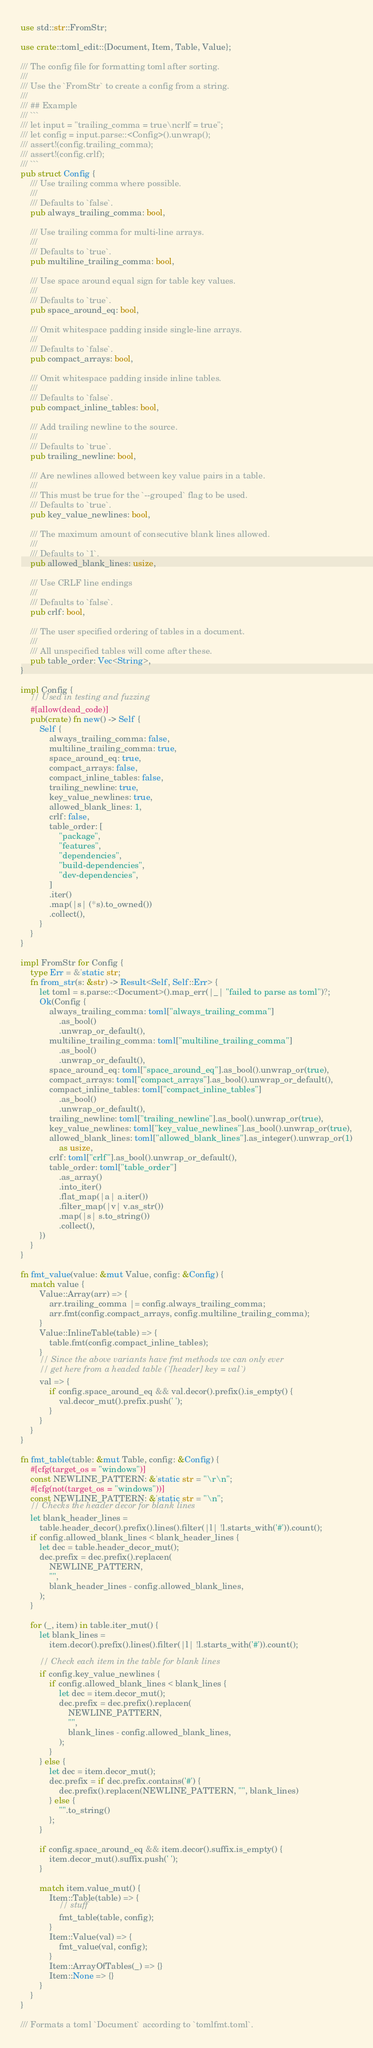Convert code to text. <code><loc_0><loc_0><loc_500><loc_500><_Rust_>use std::str::FromStr;

use crate::toml_edit::{Document, Item, Table, Value};

/// The config file for formatting toml after sorting.
///
/// Use the `FromStr` to create a config from a string.
///
/// ## Example
/// ```
/// let input = "trailing_comma = true\ncrlf = true";
/// let config = input.parse::<Config>().unwrap();
/// assert!(config.trailing_comma);
/// assert!(config.crlf);
/// ```
pub struct Config {
    /// Use trailing comma where possible.
    ///
    /// Defaults to `false`.
    pub always_trailing_comma: bool,

    /// Use trailing comma for multi-line arrays.
    ///
    /// Defaults to `true`.
    pub multiline_trailing_comma: bool,

    /// Use space around equal sign for table key values.
    ///
    /// Defaults to `true`.
    pub space_around_eq: bool,

    /// Omit whitespace padding inside single-line arrays.
    ///
    /// Defaults to `false`.
    pub compact_arrays: bool,

    /// Omit whitespace padding inside inline tables.
    ///
    /// Defaults to `false`.
    pub compact_inline_tables: bool,

    /// Add trailing newline to the source.
    ///
    /// Defaults to `true`.
    pub trailing_newline: bool,

    /// Are newlines allowed between key value pairs in a table.
    ///
    /// This must be true for the `--grouped` flag to be used.
    /// Defaults to `true`.
    pub key_value_newlines: bool,

    /// The maximum amount of consecutive blank lines allowed.
    ///
    /// Defaults to `1`.
    pub allowed_blank_lines: usize,

    /// Use CRLF line endings
    ///
    /// Defaults to `false`.
    pub crlf: bool,

    /// The user specified ordering of tables in a document.
    ///
    /// All unspecified tables will come after these.
    pub table_order: Vec<String>,
}

impl Config {
    // Used in testing and fuzzing
    #[allow(dead_code)]
    pub(crate) fn new() -> Self {
        Self {
            always_trailing_comma: false,
            multiline_trailing_comma: true,
            space_around_eq: true,
            compact_arrays: false,
            compact_inline_tables: false,
            trailing_newline: true,
            key_value_newlines: true,
            allowed_blank_lines: 1,
            crlf: false,
            table_order: [
                "package",
                "features",
                "dependencies",
                "build-dependencies",
                "dev-dependencies",
            ]
            .iter()
            .map(|s| (*s).to_owned())
            .collect(),
        }
    }
}

impl FromStr for Config {
    type Err = &'static str;
    fn from_str(s: &str) -> Result<Self, Self::Err> {
        let toml = s.parse::<Document>().map_err(|_| "failed to parse as toml")?;
        Ok(Config {
            always_trailing_comma: toml["always_trailing_comma"]
                .as_bool()
                .unwrap_or_default(),
            multiline_trailing_comma: toml["multiline_trailing_comma"]
                .as_bool()
                .unwrap_or_default(),
            space_around_eq: toml["space_around_eq"].as_bool().unwrap_or(true),
            compact_arrays: toml["compact_arrays"].as_bool().unwrap_or_default(),
            compact_inline_tables: toml["compact_inline_tables"]
                .as_bool()
                .unwrap_or_default(),
            trailing_newline: toml["trailing_newline"].as_bool().unwrap_or(true),
            key_value_newlines: toml["key_value_newlines"].as_bool().unwrap_or(true),
            allowed_blank_lines: toml["allowed_blank_lines"].as_integer().unwrap_or(1)
                as usize,
            crlf: toml["crlf"].as_bool().unwrap_or_default(),
            table_order: toml["table_order"]
                .as_array()
                .into_iter()
                .flat_map(|a| a.iter())
                .filter_map(|v| v.as_str())
                .map(|s| s.to_string())
                .collect(),
        })
    }
}

fn fmt_value(value: &mut Value, config: &Config) {
    match value {
        Value::Array(arr) => {
            arr.trailing_comma |= config.always_trailing_comma;
            arr.fmt(config.compact_arrays, config.multiline_trailing_comma);
        }
        Value::InlineTable(table) => {
            table.fmt(config.compact_inline_tables);
        }
        // Since the above variants have fmt methods we can only ever
        // get here from a headed table (`[header] key = val`)
        val => {
            if config.space_around_eq && val.decor().prefix().is_empty() {
                val.decor_mut().prefix.push(' ');
            }
        }
    }
}

fn fmt_table(table: &mut Table, config: &Config) {
    #[cfg(target_os = "windows")]
    const NEWLINE_PATTERN: &'static str = "\r\n";
    #[cfg(not(target_os = "windows"))]
    const NEWLINE_PATTERN: &'static str = "\n";
    // Checks the header decor for blank lines
    let blank_header_lines =
        table.header_decor().prefix().lines().filter(|l| !l.starts_with('#')).count();
    if config.allowed_blank_lines < blank_header_lines {
        let dec = table.header_decor_mut();
        dec.prefix = dec.prefix().replacen(
            NEWLINE_PATTERN,
            "",
            blank_header_lines - config.allowed_blank_lines,
        );
    }

    for (_, item) in table.iter_mut() {
        let blank_lines =
            item.decor().prefix().lines().filter(|l| !l.starts_with('#')).count();

        // Check each item in the table for blank lines
        if config.key_value_newlines {
            if config.allowed_blank_lines < blank_lines {
                let dec = item.decor_mut();
                dec.prefix = dec.prefix().replacen(
                    NEWLINE_PATTERN,
                    "",
                    blank_lines - config.allowed_blank_lines,
                );
            }
        } else {
            let dec = item.decor_mut();
            dec.prefix = if dec.prefix.contains('#') {
                dec.prefix().replacen(NEWLINE_PATTERN, "", blank_lines)
            } else {
                "".to_string()
            };
        }

        if config.space_around_eq && item.decor().suffix.is_empty() {
            item.decor_mut().suffix.push(' ');
        }

        match item.value_mut() {
            Item::Table(table) => {
                // stuff
                fmt_table(table, config);
            }
            Item::Value(val) => {
                fmt_value(val, config);
            }
            Item::ArrayOfTables(_) => {}
            Item::None => {}
        }
    }
}

/// Formats a toml `Document` according to `tomlfmt.toml`.</code> 